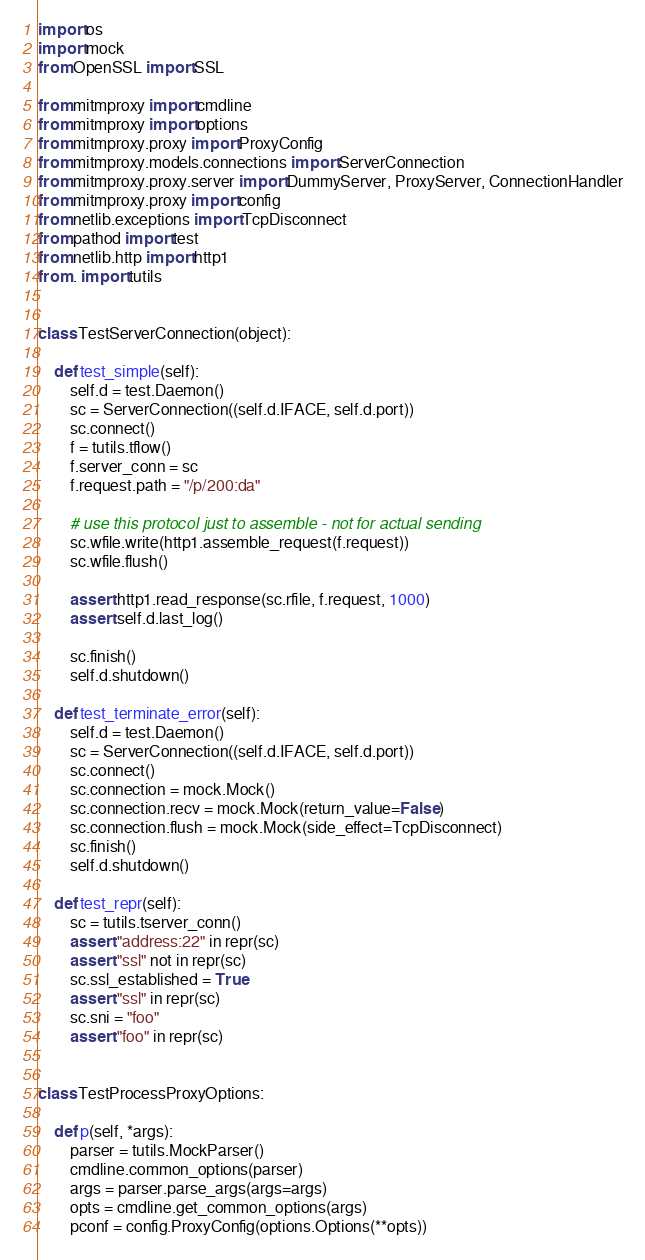<code> <loc_0><loc_0><loc_500><loc_500><_Python_>import os
import mock
from OpenSSL import SSL

from mitmproxy import cmdline
from mitmproxy import options
from mitmproxy.proxy import ProxyConfig
from mitmproxy.models.connections import ServerConnection
from mitmproxy.proxy.server import DummyServer, ProxyServer, ConnectionHandler
from mitmproxy.proxy import config
from netlib.exceptions import TcpDisconnect
from pathod import test
from netlib.http import http1
from . import tutils


class TestServerConnection(object):

    def test_simple(self):
        self.d = test.Daemon()
        sc = ServerConnection((self.d.IFACE, self.d.port))
        sc.connect()
        f = tutils.tflow()
        f.server_conn = sc
        f.request.path = "/p/200:da"

        # use this protocol just to assemble - not for actual sending
        sc.wfile.write(http1.assemble_request(f.request))
        sc.wfile.flush()

        assert http1.read_response(sc.rfile, f.request, 1000)
        assert self.d.last_log()

        sc.finish()
        self.d.shutdown()

    def test_terminate_error(self):
        self.d = test.Daemon()
        sc = ServerConnection((self.d.IFACE, self.d.port))
        sc.connect()
        sc.connection = mock.Mock()
        sc.connection.recv = mock.Mock(return_value=False)
        sc.connection.flush = mock.Mock(side_effect=TcpDisconnect)
        sc.finish()
        self.d.shutdown()

    def test_repr(self):
        sc = tutils.tserver_conn()
        assert "address:22" in repr(sc)
        assert "ssl" not in repr(sc)
        sc.ssl_established = True
        assert "ssl" in repr(sc)
        sc.sni = "foo"
        assert "foo" in repr(sc)


class TestProcessProxyOptions:

    def p(self, *args):
        parser = tutils.MockParser()
        cmdline.common_options(parser)
        args = parser.parse_args(args=args)
        opts = cmdline.get_common_options(args)
        pconf = config.ProxyConfig(options.Options(**opts))</code> 